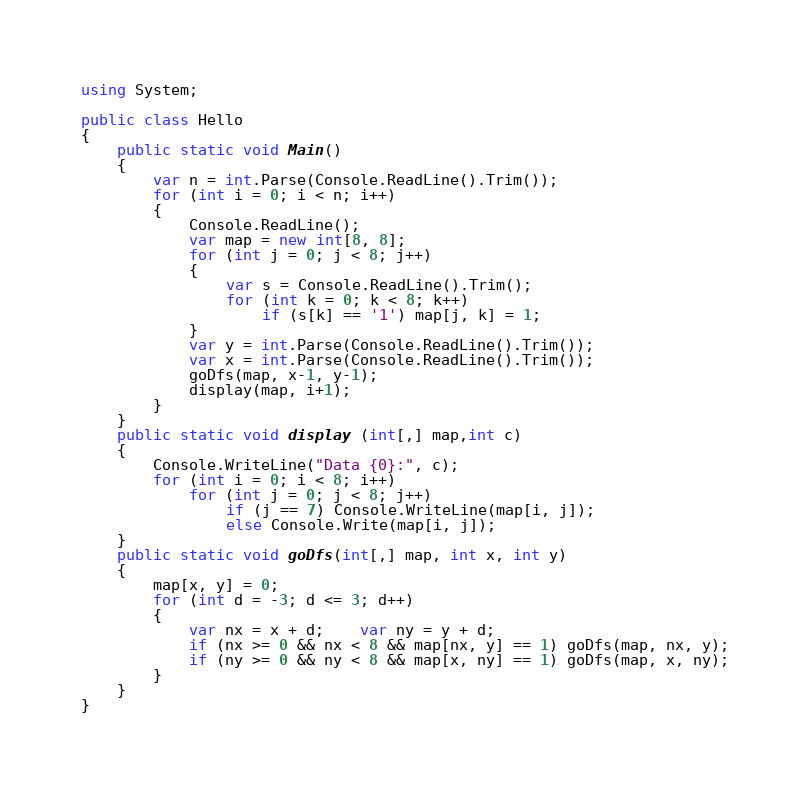Convert code to text. <code><loc_0><loc_0><loc_500><loc_500><_C#_>using System;

public class Hello
{
    public static void Main()
    {
        var n = int.Parse(Console.ReadLine().Trim());
        for (int i = 0; i < n; i++)
        {
            Console.ReadLine();
            var map = new int[8, 8];
            for (int j = 0; j < 8; j++)
            {
                var s = Console.ReadLine().Trim();
                for (int k = 0; k < 8; k++)
                    if (s[k] == '1') map[j, k] = 1;
            }
            var y = int.Parse(Console.ReadLine().Trim());
            var x = int.Parse(Console.ReadLine().Trim());
            goDfs(map, x-1, y-1);
            display(map, i+1);
        }
    }
    public static void display (int[,] map,int c)
    {
        Console.WriteLine("Data {0}:", c);
        for (int i = 0; i < 8; i++)
            for (int j = 0; j < 8; j++)
                if (j == 7) Console.WriteLine(map[i, j]);
                else Console.Write(map[i, j]);
    }
    public static void goDfs(int[,] map, int x, int y)
    {
        map[x, y] = 0;
        for (int d = -3; d <= 3; d++)
        {
            var nx = x + d;    var ny = y + d;
            if (nx >= 0 && nx < 8 && map[nx, y] == 1) goDfs(map, nx, y);
            if (ny >= 0 && ny < 8 && map[x, ny] == 1) goDfs(map, x, ny);
        }
    }
}</code> 